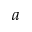Convert formula to latex. <formula><loc_0><loc_0><loc_500><loc_500>a</formula> 